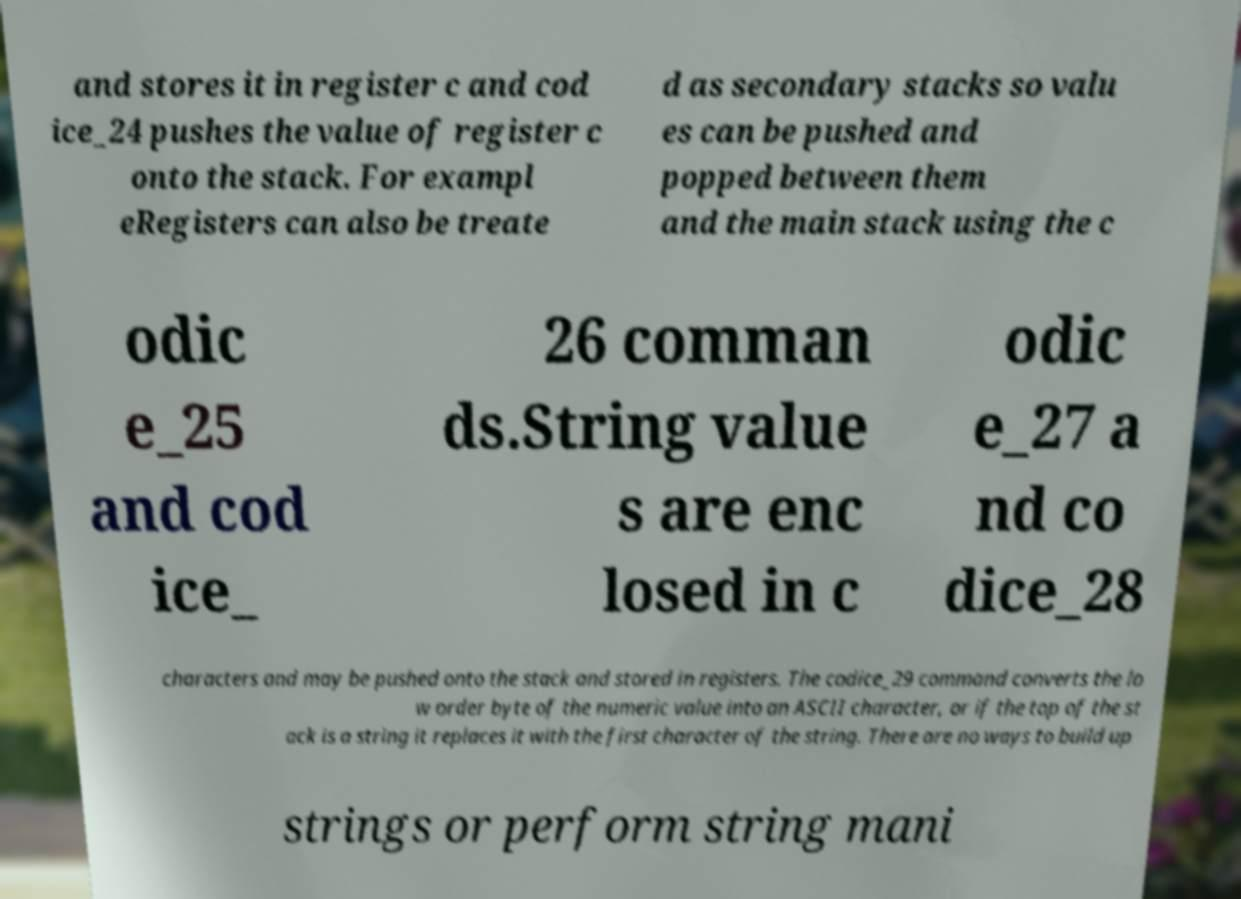Can you accurately transcribe the text from the provided image for me? and stores it in register c and cod ice_24 pushes the value of register c onto the stack. For exampl eRegisters can also be treate d as secondary stacks so valu es can be pushed and popped between them and the main stack using the c odic e_25 and cod ice_ 26 comman ds.String value s are enc losed in c odic e_27 a nd co dice_28 characters and may be pushed onto the stack and stored in registers. The codice_29 command converts the lo w order byte of the numeric value into an ASCII character, or if the top of the st ack is a string it replaces it with the first character of the string. There are no ways to build up strings or perform string mani 